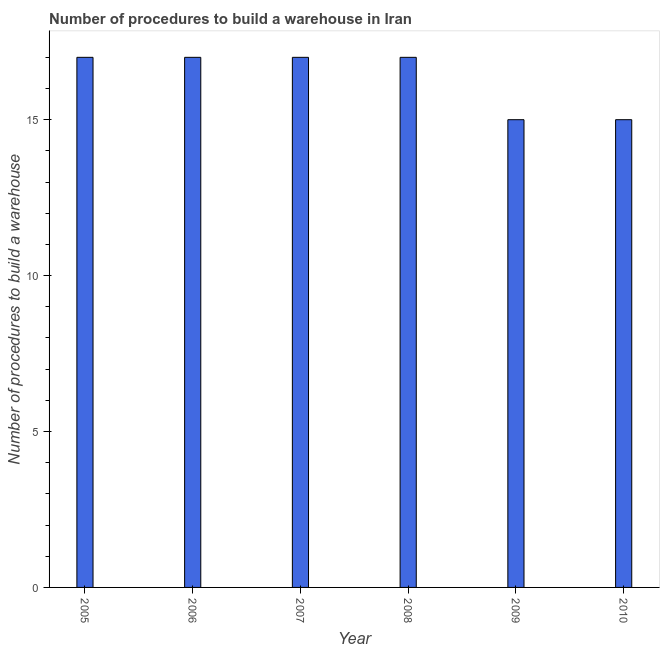Does the graph contain grids?
Your answer should be compact. No. What is the title of the graph?
Your response must be concise. Number of procedures to build a warehouse in Iran. What is the label or title of the Y-axis?
Your answer should be compact. Number of procedures to build a warehouse. What is the number of procedures to build a warehouse in 2008?
Ensure brevity in your answer.  17. Across all years, what is the maximum number of procedures to build a warehouse?
Your answer should be very brief. 17. Across all years, what is the minimum number of procedures to build a warehouse?
Your answer should be compact. 15. In which year was the number of procedures to build a warehouse minimum?
Provide a succinct answer. 2009. What is the difference between the number of procedures to build a warehouse in 2006 and 2007?
Provide a short and direct response. 0. What is the median number of procedures to build a warehouse?
Your answer should be compact. 17. Do a majority of the years between 2008 and 2007 (inclusive) have number of procedures to build a warehouse greater than 10 ?
Offer a terse response. No. What is the ratio of the number of procedures to build a warehouse in 2005 to that in 2010?
Keep it short and to the point. 1.13. Is the difference between the number of procedures to build a warehouse in 2005 and 2006 greater than the difference between any two years?
Provide a succinct answer. No. Is the sum of the number of procedures to build a warehouse in 2005 and 2008 greater than the maximum number of procedures to build a warehouse across all years?
Keep it short and to the point. Yes. What is the difference between the highest and the lowest number of procedures to build a warehouse?
Your answer should be very brief. 2. How many bars are there?
Offer a terse response. 6. How many years are there in the graph?
Keep it short and to the point. 6. Are the values on the major ticks of Y-axis written in scientific E-notation?
Your answer should be compact. No. What is the Number of procedures to build a warehouse in 2005?
Give a very brief answer. 17. What is the Number of procedures to build a warehouse of 2006?
Offer a terse response. 17. What is the Number of procedures to build a warehouse in 2009?
Provide a short and direct response. 15. What is the difference between the Number of procedures to build a warehouse in 2005 and 2006?
Offer a very short reply. 0. What is the difference between the Number of procedures to build a warehouse in 2005 and 2008?
Give a very brief answer. 0. What is the difference between the Number of procedures to build a warehouse in 2005 and 2010?
Keep it short and to the point. 2. What is the difference between the Number of procedures to build a warehouse in 2006 and 2009?
Offer a very short reply. 2. What is the difference between the Number of procedures to build a warehouse in 2007 and 2008?
Provide a succinct answer. 0. What is the difference between the Number of procedures to build a warehouse in 2007 and 2009?
Your response must be concise. 2. What is the difference between the Number of procedures to build a warehouse in 2007 and 2010?
Your answer should be very brief. 2. What is the ratio of the Number of procedures to build a warehouse in 2005 to that in 2007?
Offer a terse response. 1. What is the ratio of the Number of procedures to build a warehouse in 2005 to that in 2009?
Give a very brief answer. 1.13. What is the ratio of the Number of procedures to build a warehouse in 2005 to that in 2010?
Offer a terse response. 1.13. What is the ratio of the Number of procedures to build a warehouse in 2006 to that in 2007?
Make the answer very short. 1. What is the ratio of the Number of procedures to build a warehouse in 2006 to that in 2009?
Your answer should be very brief. 1.13. What is the ratio of the Number of procedures to build a warehouse in 2006 to that in 2010?
Make the answer very short. 1.13. What is the ratio of the Number of procedures to build a warehouse in 2007 to that in 2009?
Offer a very short reply. 1.13. What is the ratio of the Number of procedures to build a warehouse in 2007 to that in 2010?
Your answer should be very brief. 1.13. What is the ratio of the Number of procedures to build a warehouse in 2008 to that in 2009?
Offer a very short reply. 1.13. What is the ratio of the Number of procedures to build a warehouse in 2008 to that in 2010?
Your response must be concise. 1.13. 